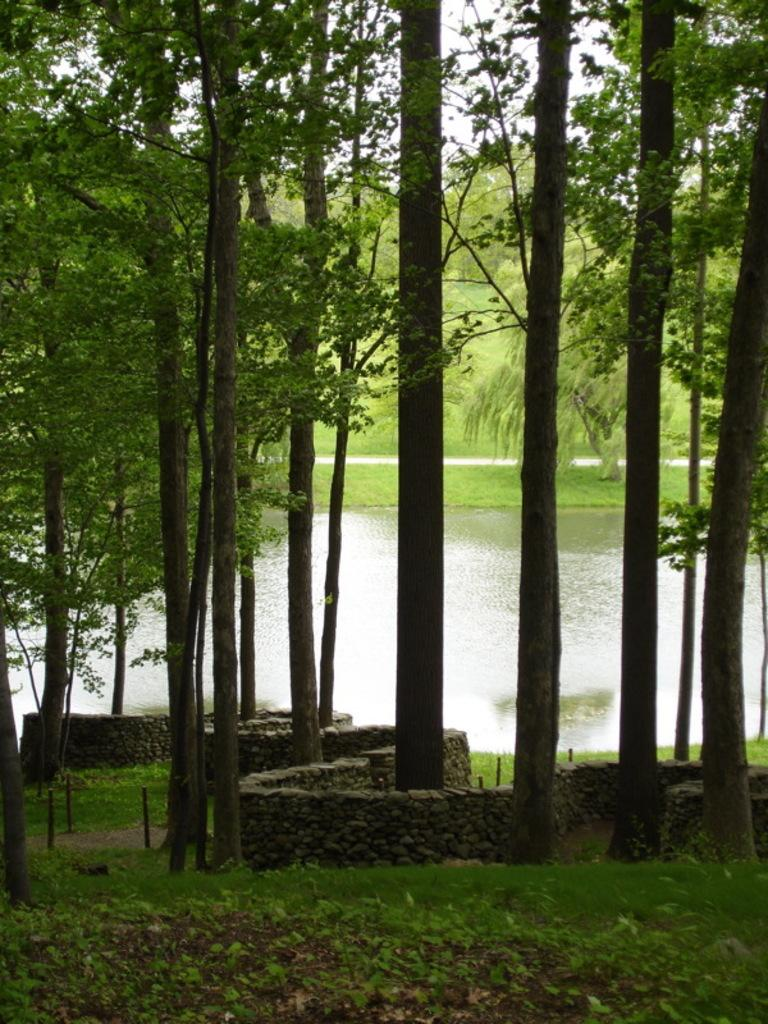What type of vegetation can be seen in the image? There are trees in the image. What is located in the middle of the image? There is water in the middle of the image. What type of unit can be seen in the image? There is no unit present in the image. Is there a lock visible in the image? There is no lock present in the image. 